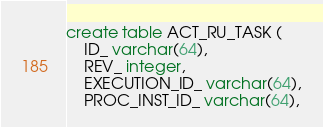Convert code to text. <code><loc_0><loc_0><loc_500><loc_500><_SQL_>create table ACT_RU_TASK (
    ID_ varchar(64),
    REV_ integer,
    EXECUTION_ID_ varchar(64),
    PROC_INST_ID_ varchar(64),</code> 